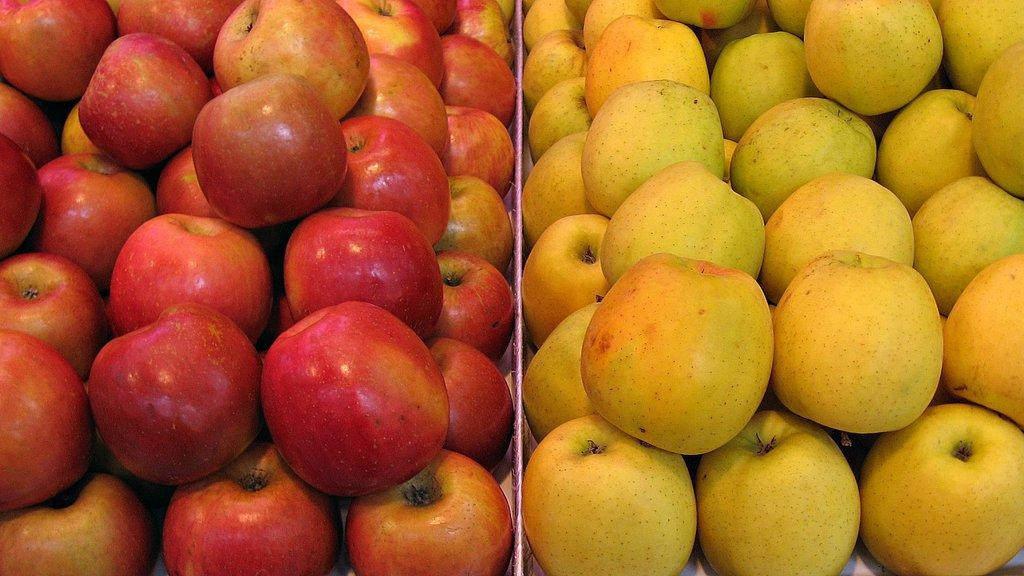What types of fruits are present in the image? There are two types of apples in the image. How are the apples stored in the image? The apples are kept in a box. Where might this image have been taken? The image might have been taken in a shop, as it contains fruits that are often sold in stores. What type of jeans can be seen hanging on the lumber in the image? There is no mention of jeans or lumber in the image; it only contains two types of apples stored in a box. 